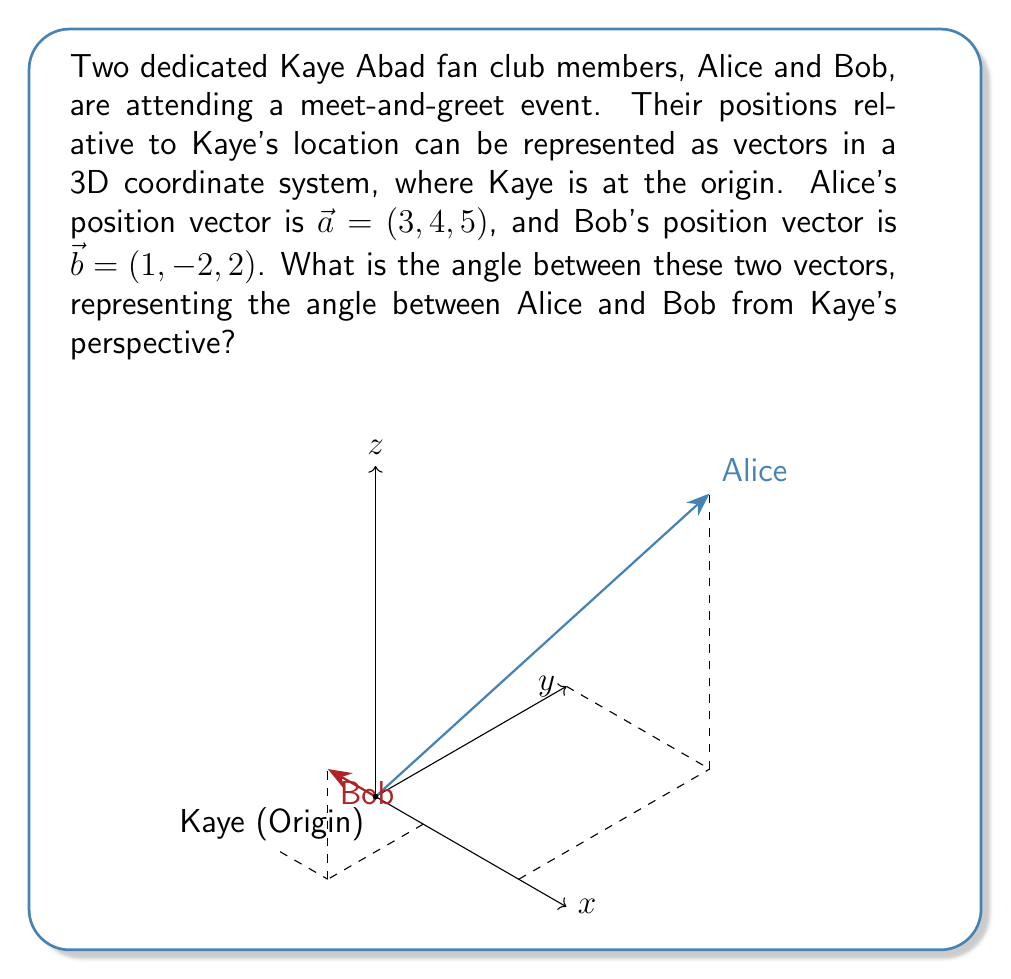Can you solve this math problem? To find the angle between two vectors, we can use the dot product formula:

$$\cos \theta = \frac{\vec{a} \cdot \vec{b}}{|\vec{a}||\vec{b}|}$$

Step 1: Calculate the dot product $\vec{a} \cdot \vec{b}$
$$\vec{a} \cdot \vec{b} = (3)(1) + (4)(-2) + (5)(2) = 3 - 8 + 10 = 5$$

Step 2: Calculate the magnitudes of $\vec{a}$ and $\vec{b}$
$$|\vec{a}| = \sqrt{3^2 + 4^2 + 5^2} = \sqrt{9 + 16 + 25} = \sqrt{50}$$
$$|\vec{b}| = \sqrt{1^2 + (-2)^2 + 2^2} = \sqrt{1 + 4 + 4} = 3$$

Step 3: Substitute into the formula
$$\cos \theta = \frac{5}{\sqrt{50} \cdot 3}$$

Step 4: Simplify
$$\cos \theta = \frac{5}{3\sqrt{50}} = \frac{5}{3\sqrt{2} \cdot 5} = \frac{1}{3\sqrt{2}}$$

Step 5: Take the inverse cosine (arccos) of both sides
$$\theta = \arccos(\frac{1}{3\sqrt{2}})$$

Step 6: Calculate the final result (rounded to 2 decimal places)
$$\theta \approx 1.27 \text{ radians} \approx 72.77°$$
Answer: $72.77°$ or $1.27$ radians 